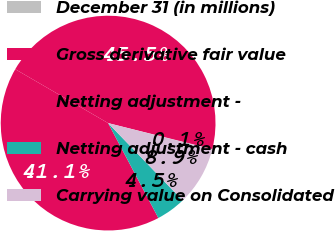Convert chart. <chart><loc_0><loc_0><loc_500><loc_500><pie_chart><fcel>December 31 (in millions)<fcel>Gross derivative fair value<fcel>Netting adjustment -<fcel>Netting adjustment - cash<fcel>Carrying value on Consolidated<nl><fcel>0.06%<fcel>45.52%<fcel>41.12%<fcel>4.45%<fcel>8.85%<nl></chart> 